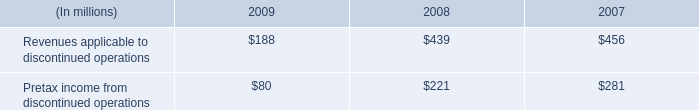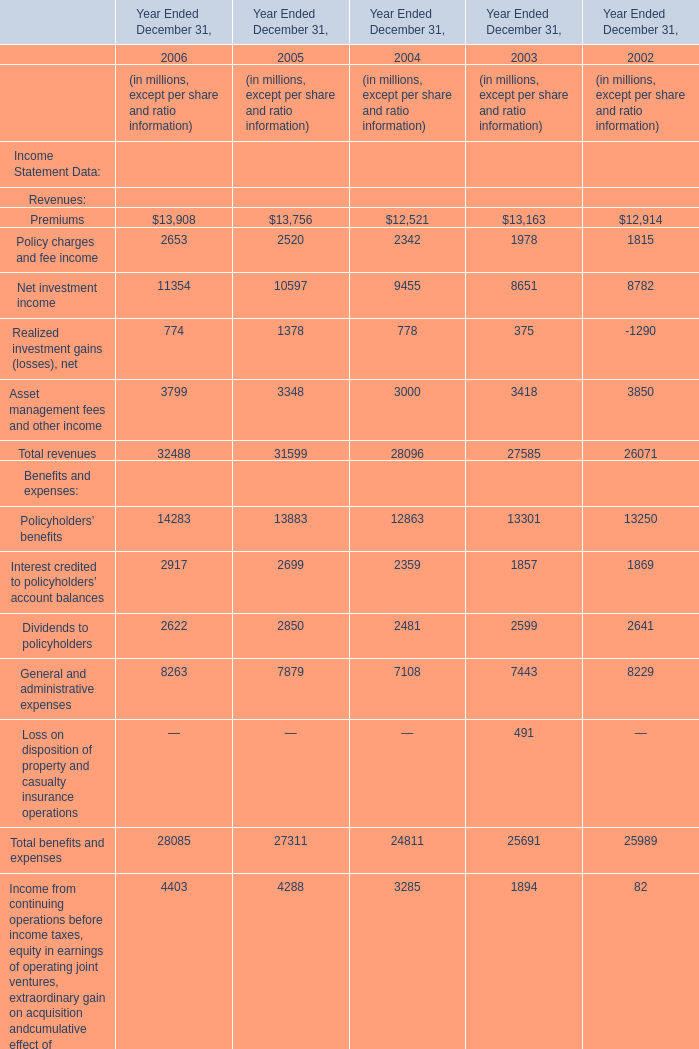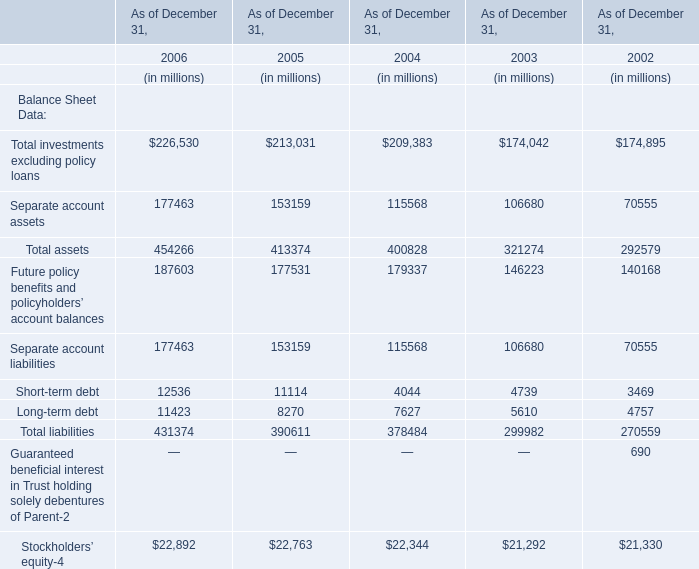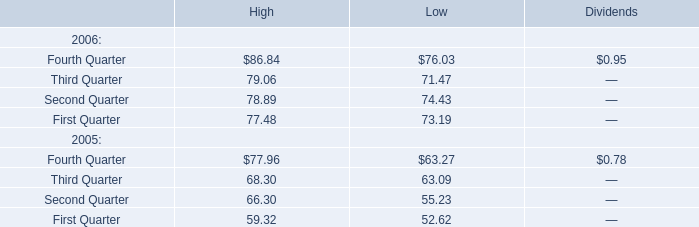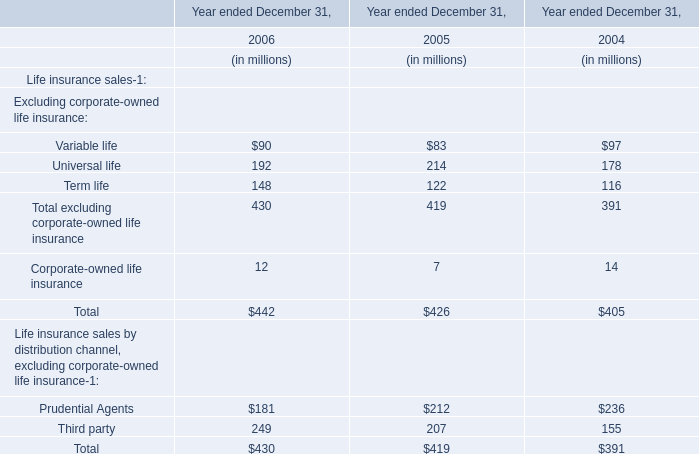What is the ratio of all Benefits and expenses that are in the range of 3000 and 15000 to the sum of Benefits and expenses, in 2005? (in %) 
Computations: ((13883 + 7879) / 27311)
Answer: 0.79682. 